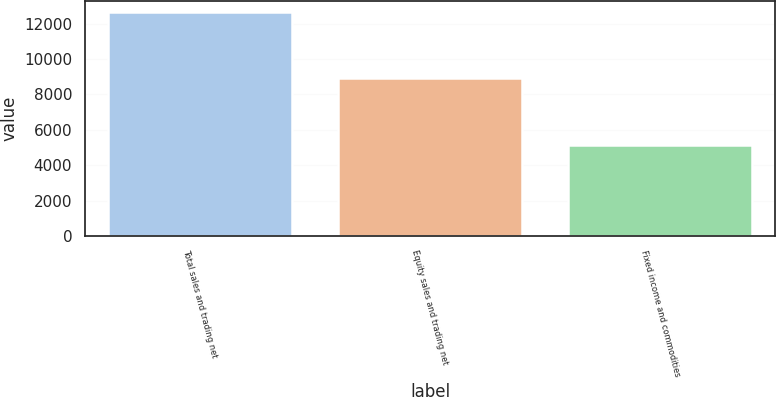Convert chart to OTSL. <chart><loc_0><loc_0><loc_500><loc_500><bar_chart><fcel>Total sales and trading net<fcel>Equity sales and trading net<fcel>Fixed income and commodities<nl><fcel>12646.7<fcel>8939.7<fcel>5117.7<nl></chart> 